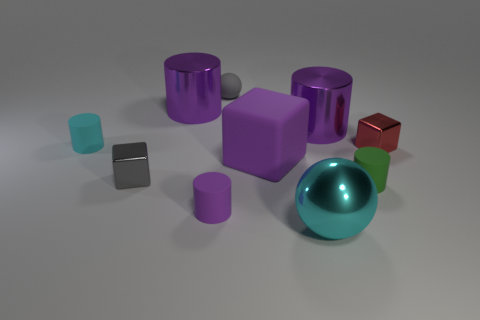What shape is the shiny thing that is the same color as the matte ball?
Give a very brief answer. Cube. There is a gray shiny object; does it have the same size as the purple rubber object that is behind the small green thing?
Provide a succinct answer. No. What is the color of the cylinder that is both behind the small green cylinder and to the right of the gray matte thing?
Your response must be concise. Purple. Is the number of small green matte things left of the big rubber cube greater than the number of rubber objects on the left side of the small sphere?
Your answer should be very brief. No. There is a cyan thing that is made of the same material as the gray ball; what is its size?
Provide a succinct answer. Small. How many gray things are behind the small block to the left of the green cylinder?
Provide a succinct answer. 1. Are there any big purple objects of the same shape as the cyan shiny object?
Provide a succinct answer. No. What color is the sphere in front of the small metallic block that is on the right side of the cyan sphere?
Offer a terse response. Cyan. Is the number of tiny blocks greater than the number of big purple blocks?
Give a very brief answer. Yes. What number of cyan shiny spheres are the same size as the cyan rubber object?
Offer a very short reply. 0. 